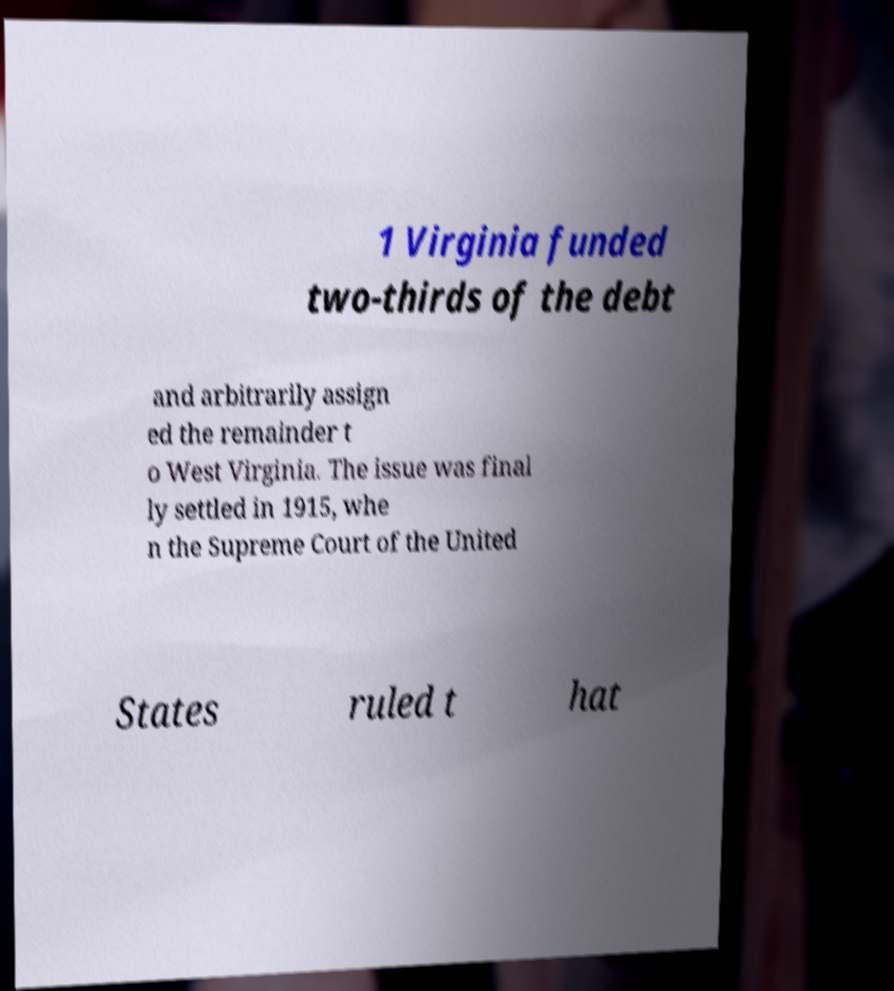Could you assist in decoding the text presented in this image and type it out clearly? 1 Virginia funded two-thirds of the debt and arbitrarily assign ed the remainder t o West Virginia. The issue was final ly settled in 1915, whe n the Supreme Court of the United States ruled t hat 